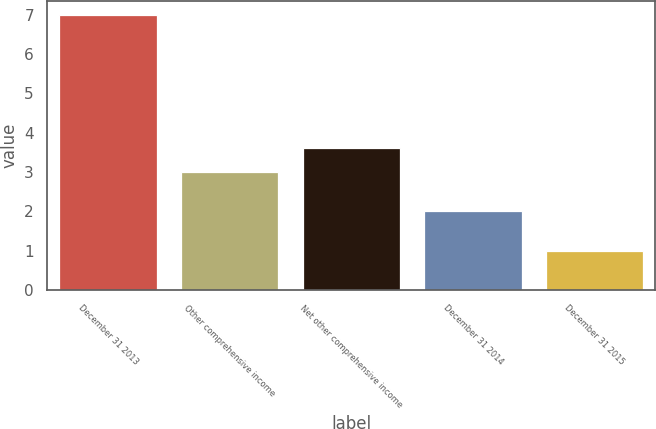Convert chart. <chart><loc_0><loc_0><loc_500><loc_500><bar_chart><fcel>December 31 2013<fcel>Other comprehensive income<fcel>Net other comprehensive income<fcel>December 31 2014<fcel>December 31 2015<nl><fcel>7<fcel>3<fcel>3.6<fcel>2<fcel>1<nl></chart> 